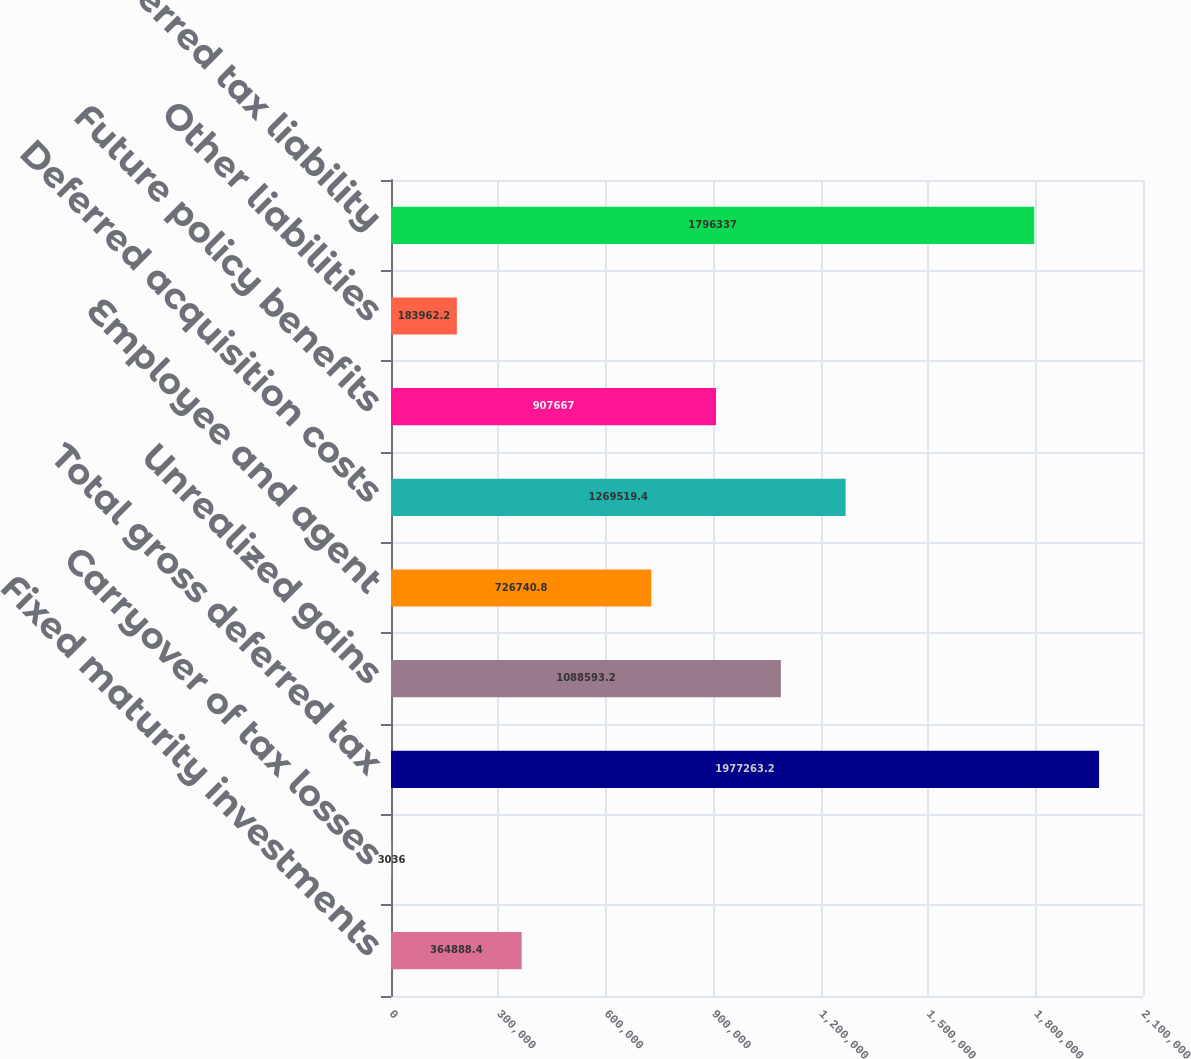Convert chart. <chart><loc_0><loc_0><loc_500><loc_500><bar_chart><fcel>Fixed maturity investments<fcel>Carryover of tax losses<fcel>Total gross deferred tax<fcel>Unrealized gains<fcel>Employee and agent<fcel>Deferred acquisition costs<fcel>Future policy benefits<fcel>Other liabilities<fcel>Net deferred tax liability<nl><fcel>364888<fcel>3036<fcel>1.97726e+06<fcel>1.08859e+06<fcel>726741<fcel>1.26952e+06<fcel>907667<fcel>183962<fcel>1.79634e+06<nl></chart> 